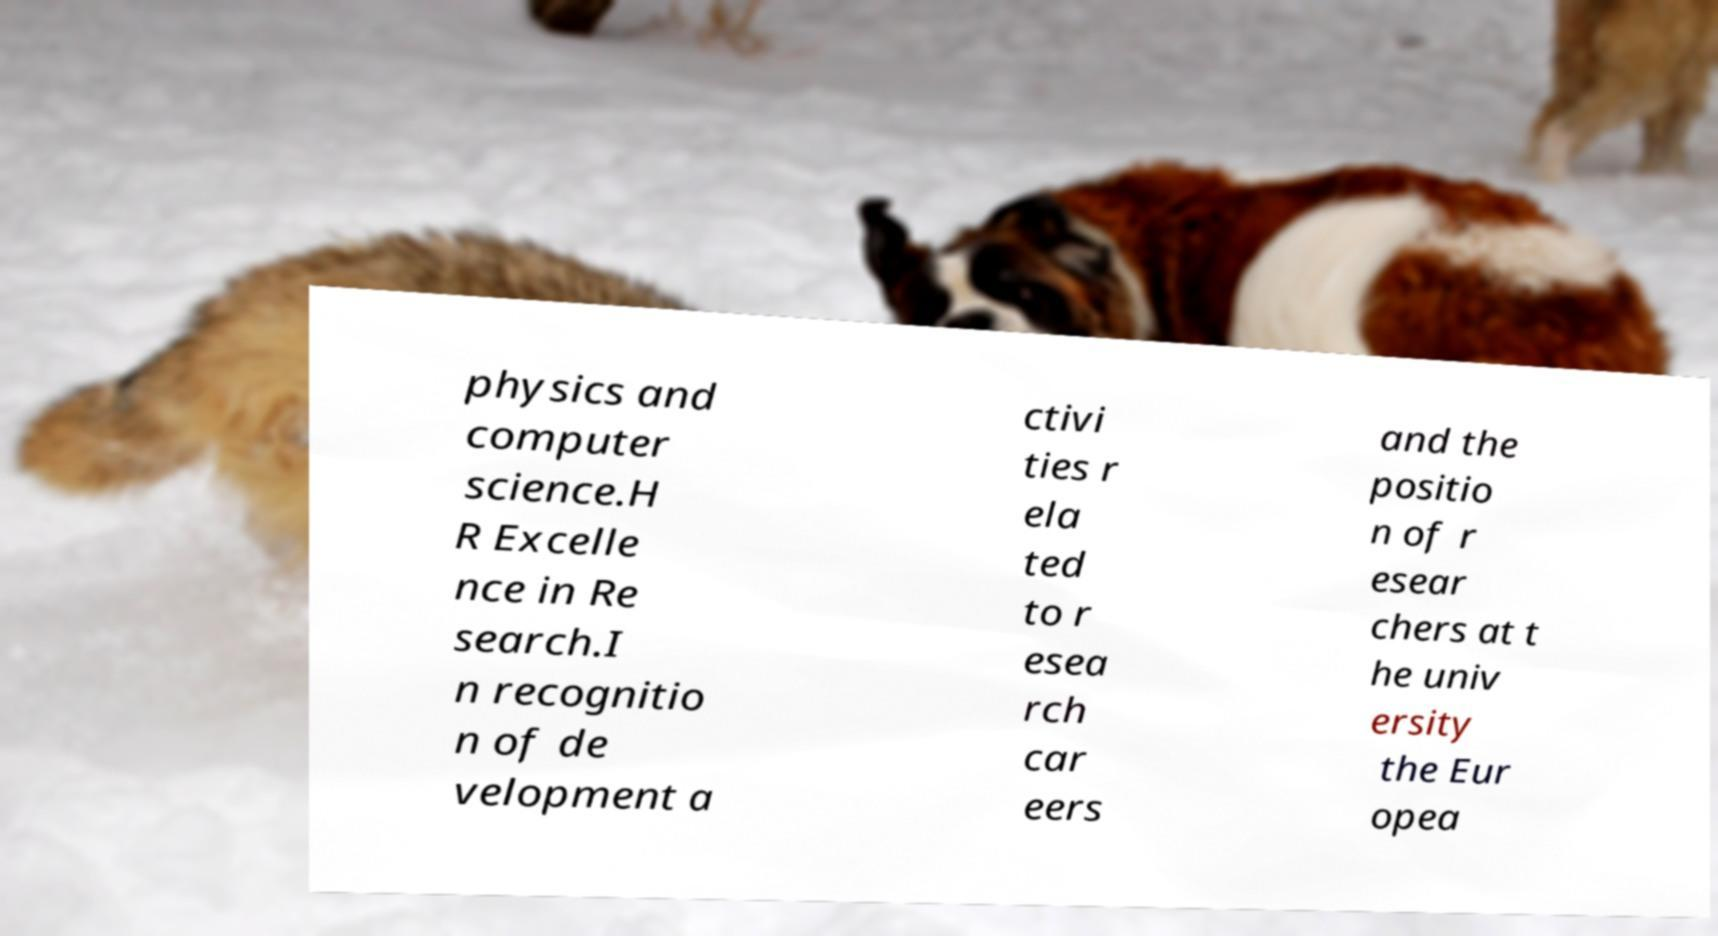Could you assist in decoding the text presented in this image and type it out clearly? physics and computer science.H R Excelle nce in Re search.I n recognitio n of de velopment a ctivi ties r ela ted to r esea rch car eers and the positio n of r esear chers at t he univ ersity the Eur opea 